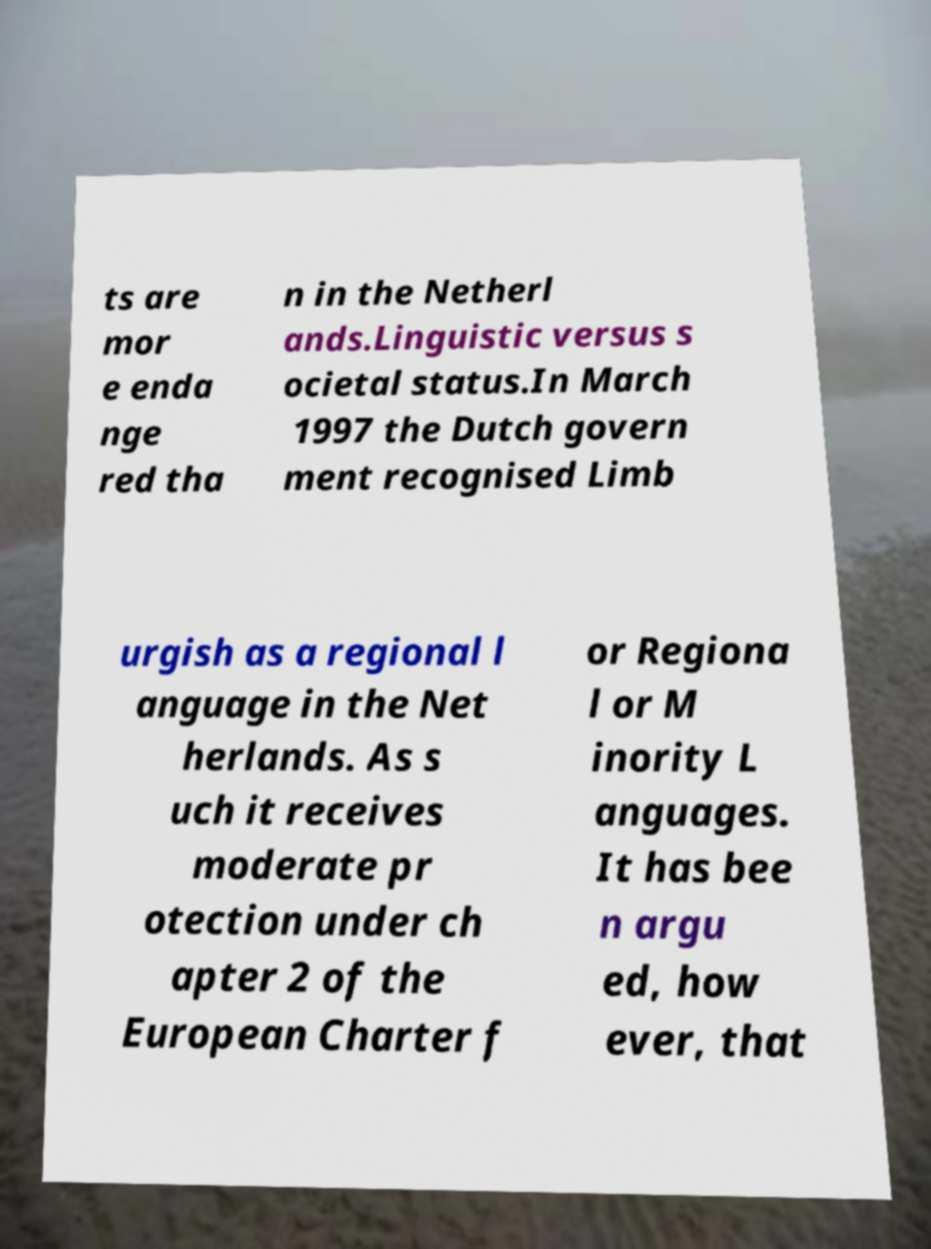I need the written content from this picture converted into text. Can you do that? ts are mor e enda nge red tha n in the Netherl ands.Linguistic versus s ocietal status.In March 1997 the Dutch govern ment recognised Limb urgish as a regional l anguage in the Net herlands. As s uch it receives moderate pr otection under ch apter 2 of the European Charter f or Regiona l or M inority L anguages. It has bee n argu ed, how ever, that 